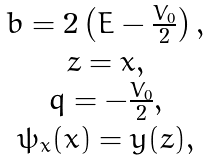<formula> <loc_0><loc_0><loc_500><loc_500>\begin{array} { c } b = 2 \left ( { E - \frac { V _ { 0 } } { 2 } } \right ) , \\ z = x , \\ q = - \frac { V _ { 0 } } { 2 } , \\ \psi _ { x } ( x ) = y ( z ) , \\ \end{array}</formula> 